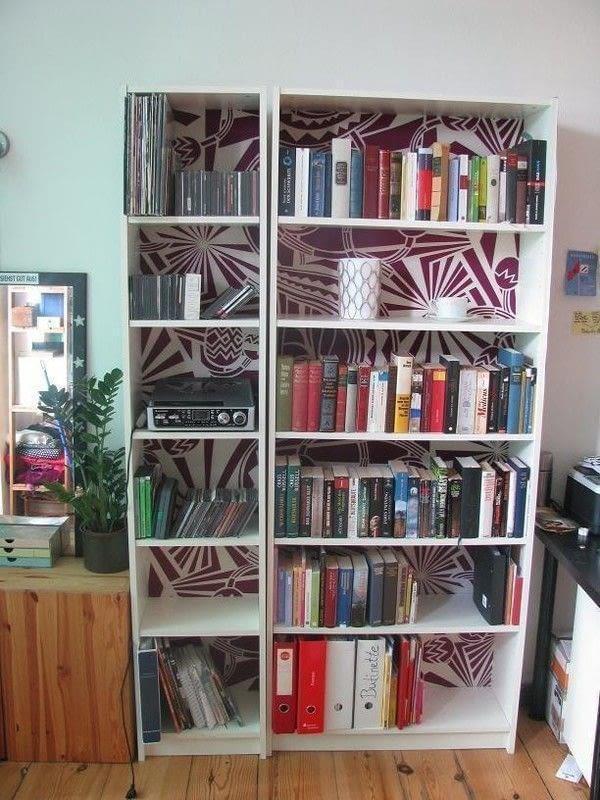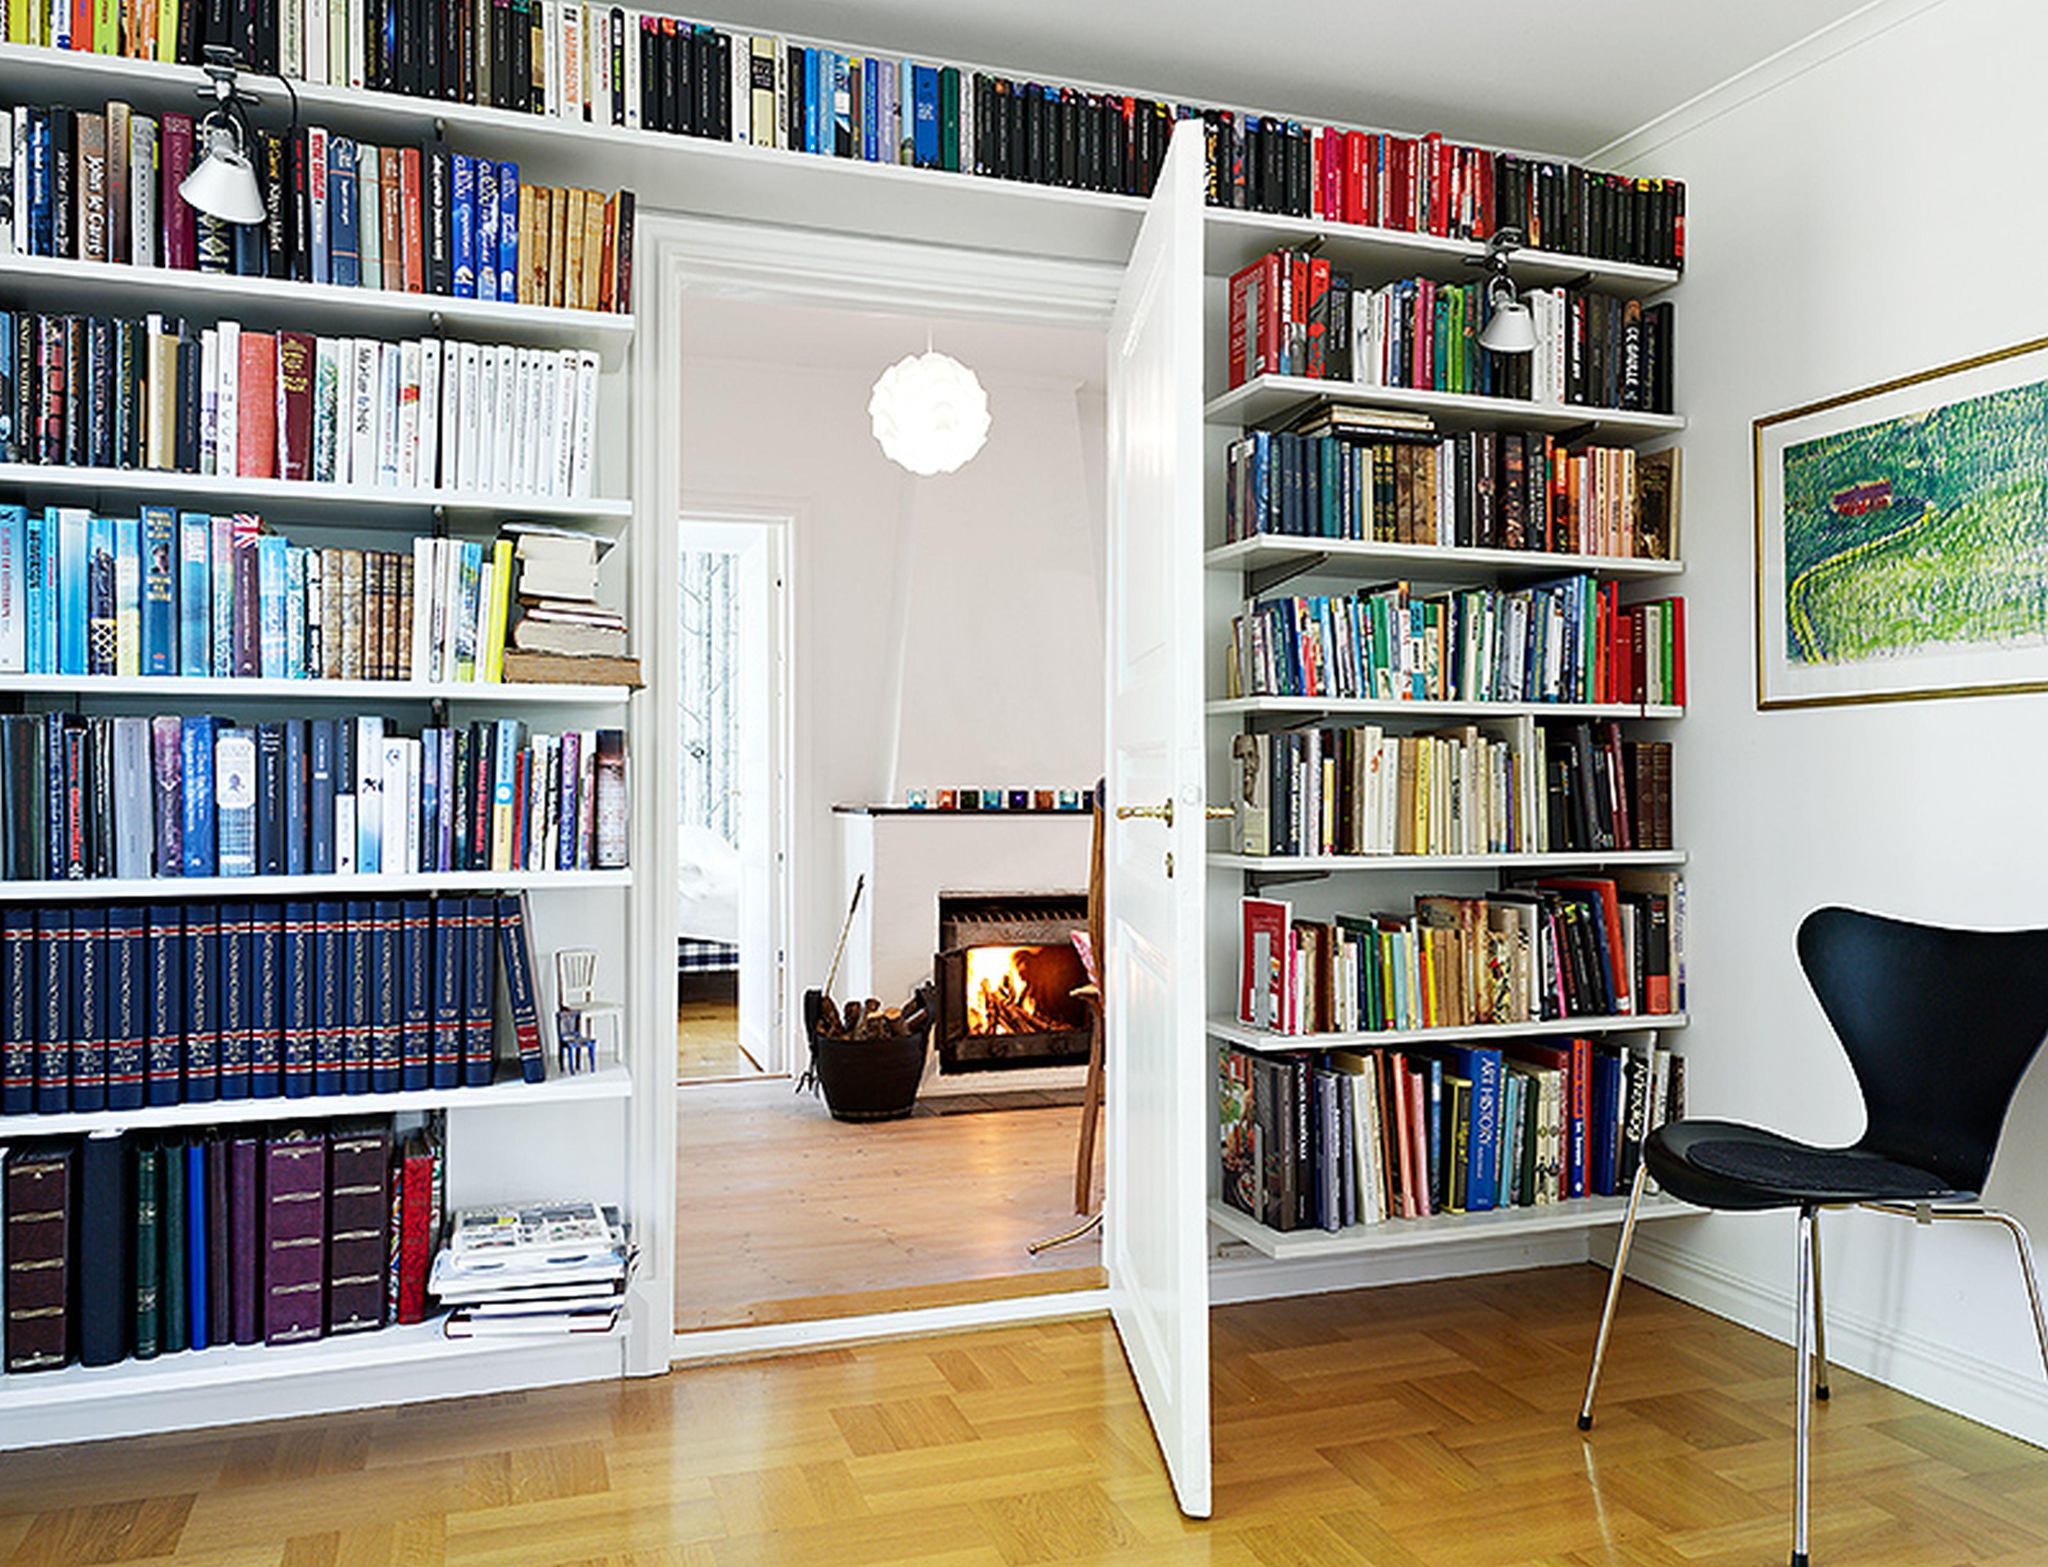The first image is the image on the left, the second image is the image on the right. Evaluate the accuracy of this statement regarding the images: "In one image, a white shelving unit surrounds a central door that is standing open, with floor-to-ceiling shelves on both sides and over the door.". Is it true? Answer yes or no. Yes. The first image is the image on the left, the second image is the image on the right. For the images displayed, is the sentence "One room has an opened doorway through the middle of a wall of white bookshelves." factually correct? Answer yes or no. Yes. 